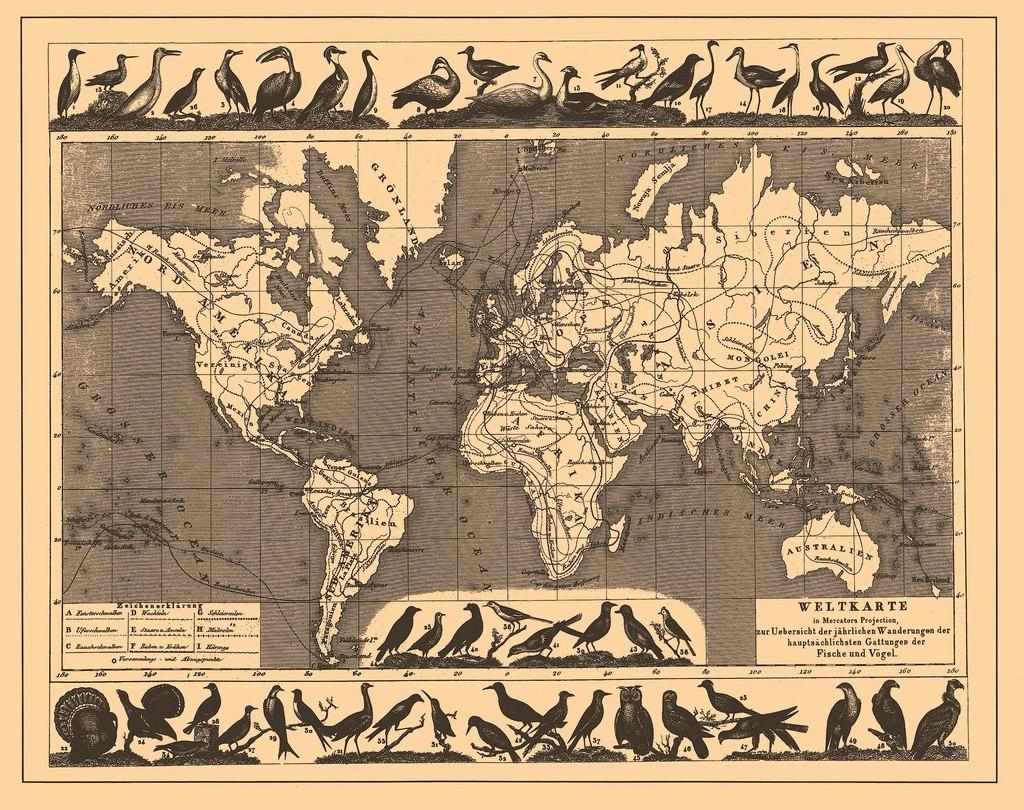<image>
Summarize the visual content of the image. A Weltkarte map of the world has a border of birds on it. 